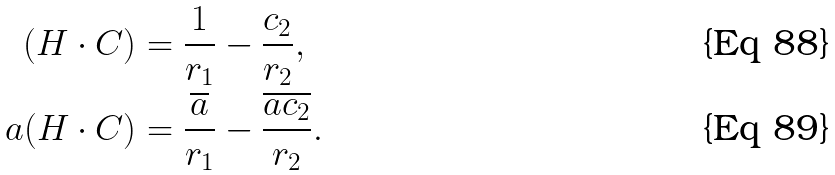Convert formula to latex. <formula><loc_0><loc_0><loc_500><loc_500>( H \cdot C ) & = \frac { 1 } { r _ { 1 } } - \frac { c _ { 2 } } { r _ { 2 } } , \\ a ( H \cdot C ) & = \frac { \overline { a } } { r _ { 1 } } - \frac { \overline { a c _ { 2 } } } { r _ { 2 } } .</formula> 